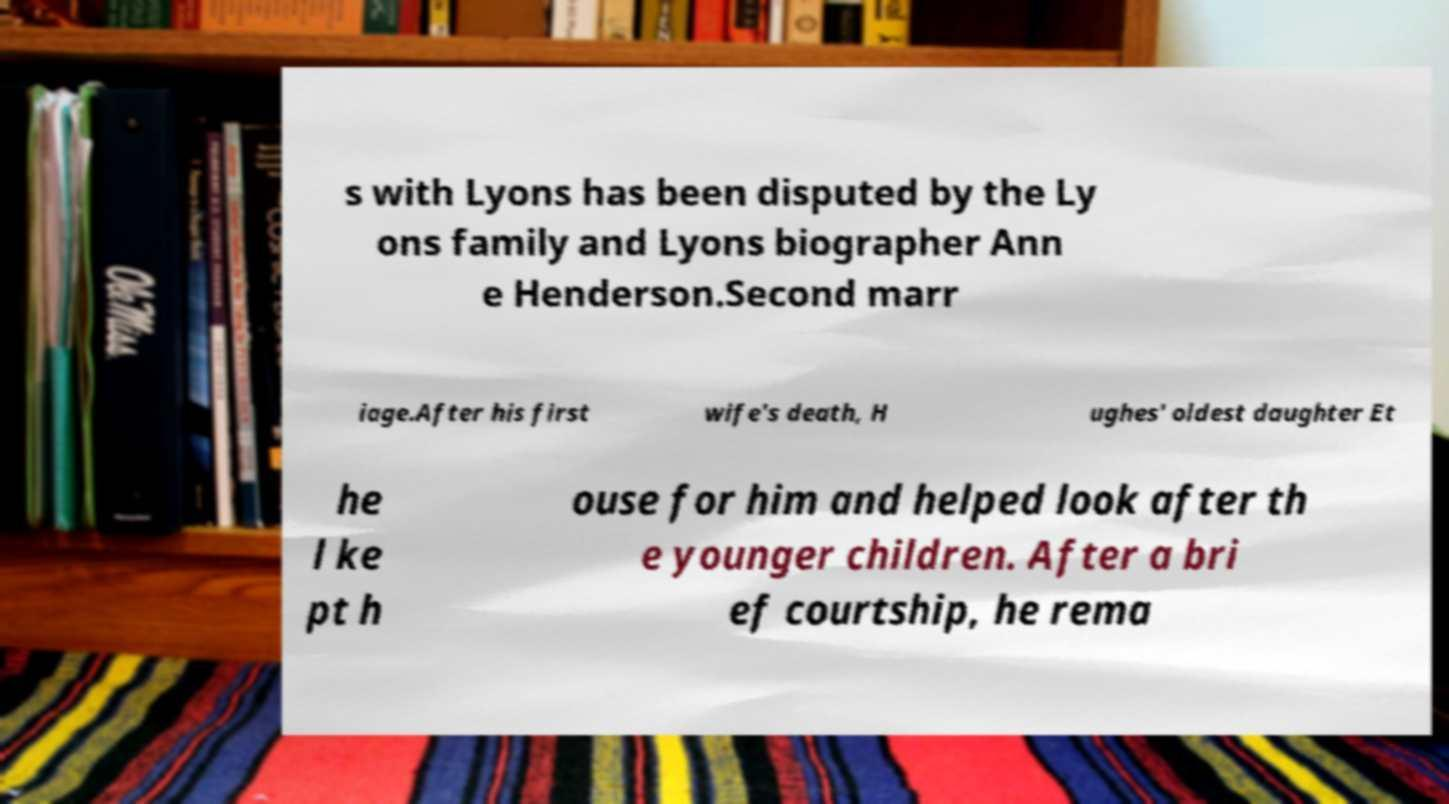What messages or text are displayed in this image? I need them in a readable, typed format. s with Lyons has been disputed by the Ly ons family and Lyons biographer Ann e Henderson.Second marr iage.After his first wife's death, H ughes' oldest daughter Et he l ke pt h ouse for him and helped look after th e younger children. After a bri ef courtship, he rema 